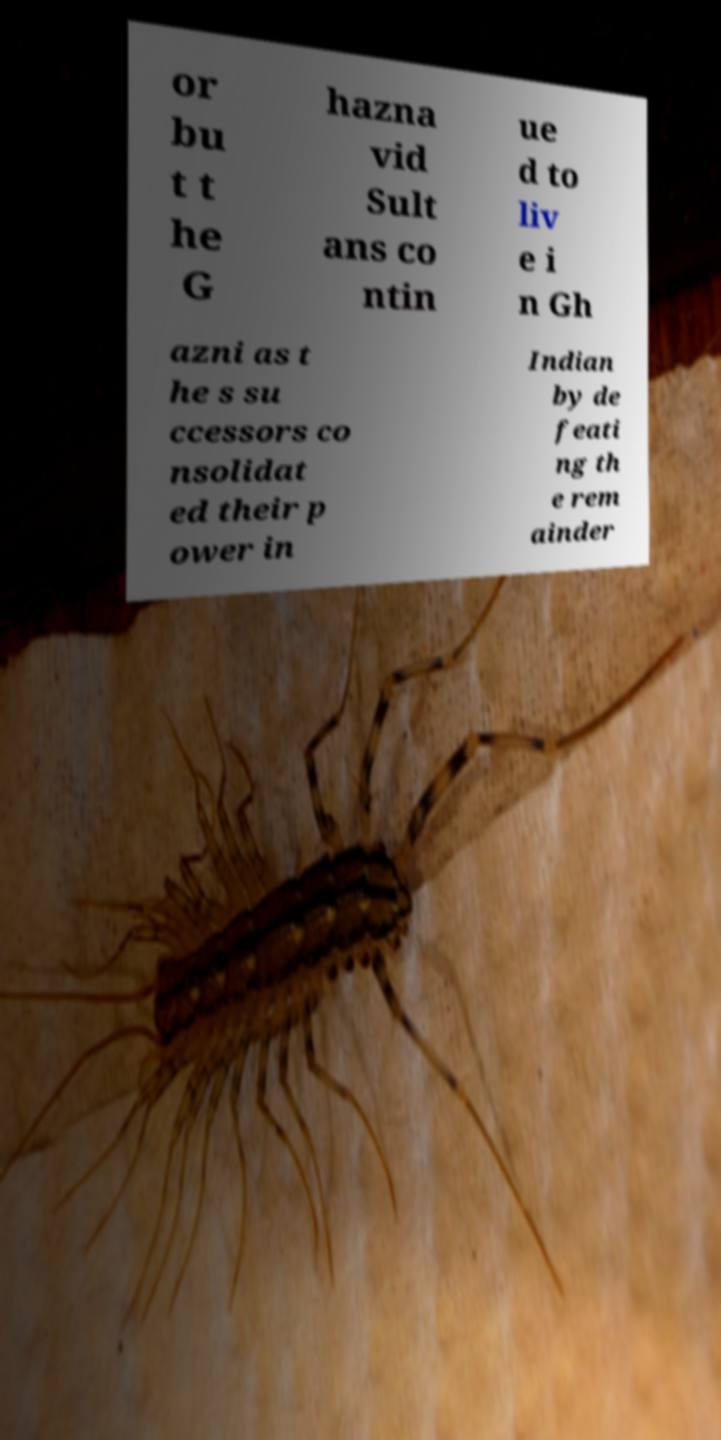There's text embedded in this image that I need extracted. Can you transcribe it verbatim? or bu t t he G hazna vid Sult ans co ntin ue d to liv e i n Gh azni as t he s su ccessors co nsolidat ed their p ower in Indian by de feati ng th e rem ainder 